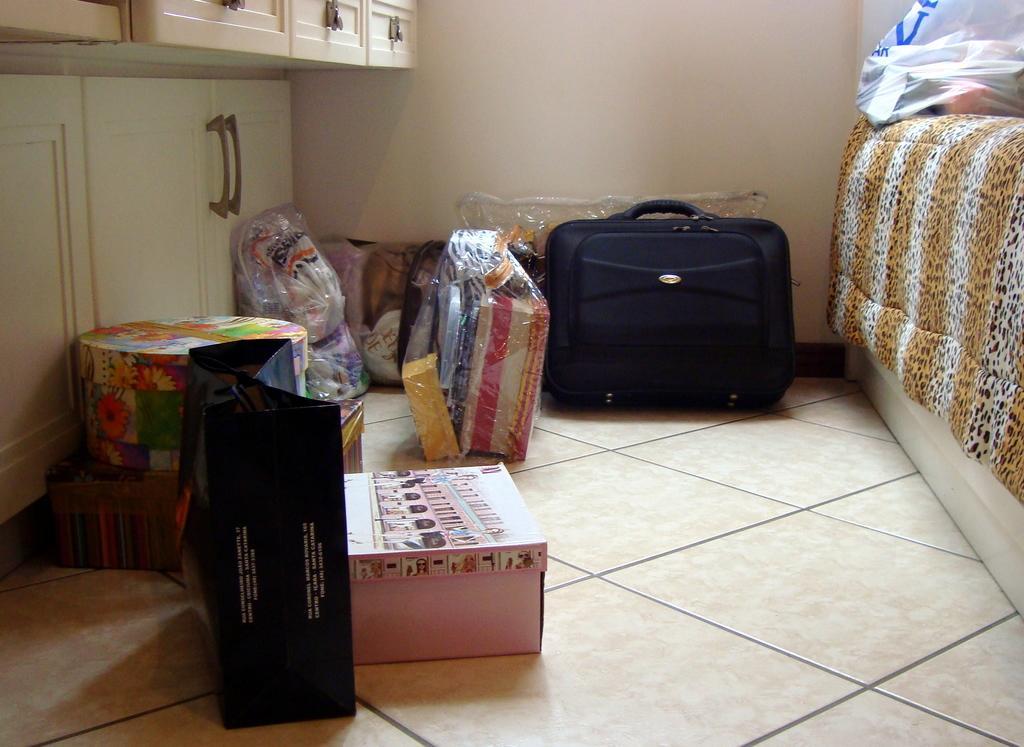In one or two sentences, can you explain what this image depicts? In this picture it seems like a room in which it has a suitcase,a cover,a box,a cloth. In the background it has a wall. In the left side it has a cupboard. 